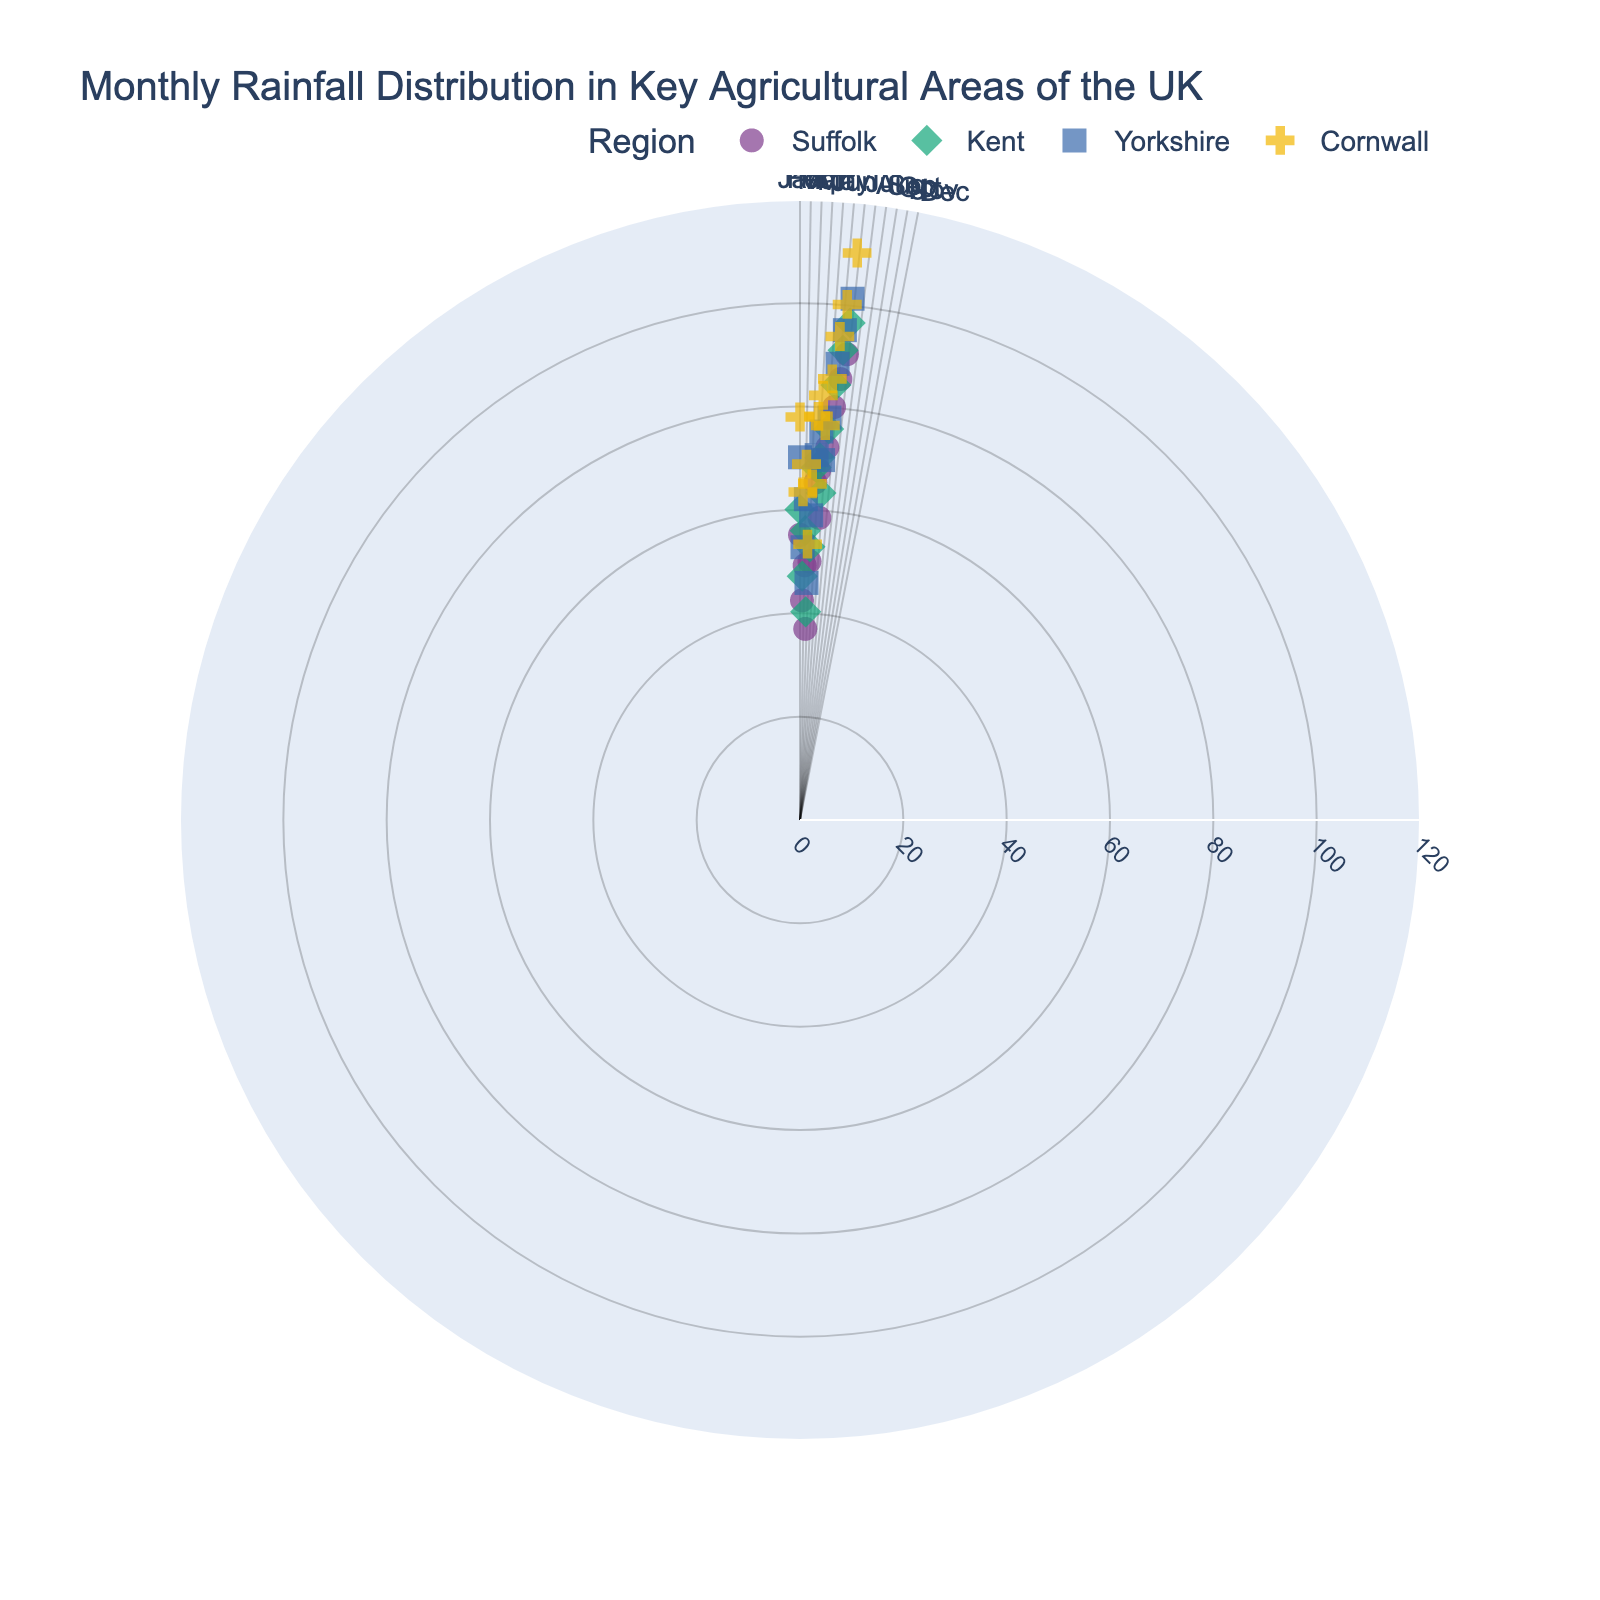What is the title of the figure? The title is displayed at the top of the figure and reads: "Monthly Rainfall Distribution in Key Agricultural Areas of the UK."
Answer: Monthly Rainfall Distribution in Key Agricultural Areas of the UK How many key agricultural areas are shown in the plot? By observing the figure, each distinct color and symbol combination represents a different region. The legend indicates that there are four regions: Suffolk, Kent, Yorkshire, and Cornwall.
Answer: 4 Which region receives the highest amount of rainfall in December? By locating the points for December and comparing the values, we see that Cornwall has the data point farthest from the center, indicating the highest rainfall for that month.
Answer: Cornwall What's the average rainfall in November for all regions? Find the November points for all regions: Suffolk (85.7 mm), Kent (91.3 mm), Yorkshire (95.2 mm), and Cornwall (100.2 mm). Sum these values and divide by 4: (85.7 + 91.3 + 95.2 + 100.2) / 4 = 372.4 / 4 = 93.1
Answer: 93.1 mm Which month in Suffolk has the lowest rainfall? By examining the figure for the month with the closest data point to the center for Suffolk, we see that February has the lowest rainfall, at 42.5 mm.
Answer: February How does the rainfall in July compare between Kent and Suffolk? Locate the July data points for both regions. Kent shows 70.2 mm, and Suffolk shows 67.8 mm. Kent has slightly more rainfall in July compared to Suffolk.
Answer: Kent has more In which month does Yorkshire experience its maximum rainfall? For Yorkshire, identify the point farthest from the center. December's point is the farthest with 101.4 mm.
Answer: December What are the symbols used to represent the regions? The legend shows that different symbols are used for each region: circle for Suffolk, diamond for Kent, square for Yorkshire, and cross for Cornwall.
Answer: Circle for Suffolk, Diamond for Kent, Square for Yorkshire, Cross for Cornwall In which month and region do we see the maximum single rainfall value? By analyzing the farthest points from the center across all months and regions, Cornwall in December has the highest value with 110.3 mm.
Answer: Cornwall, December 